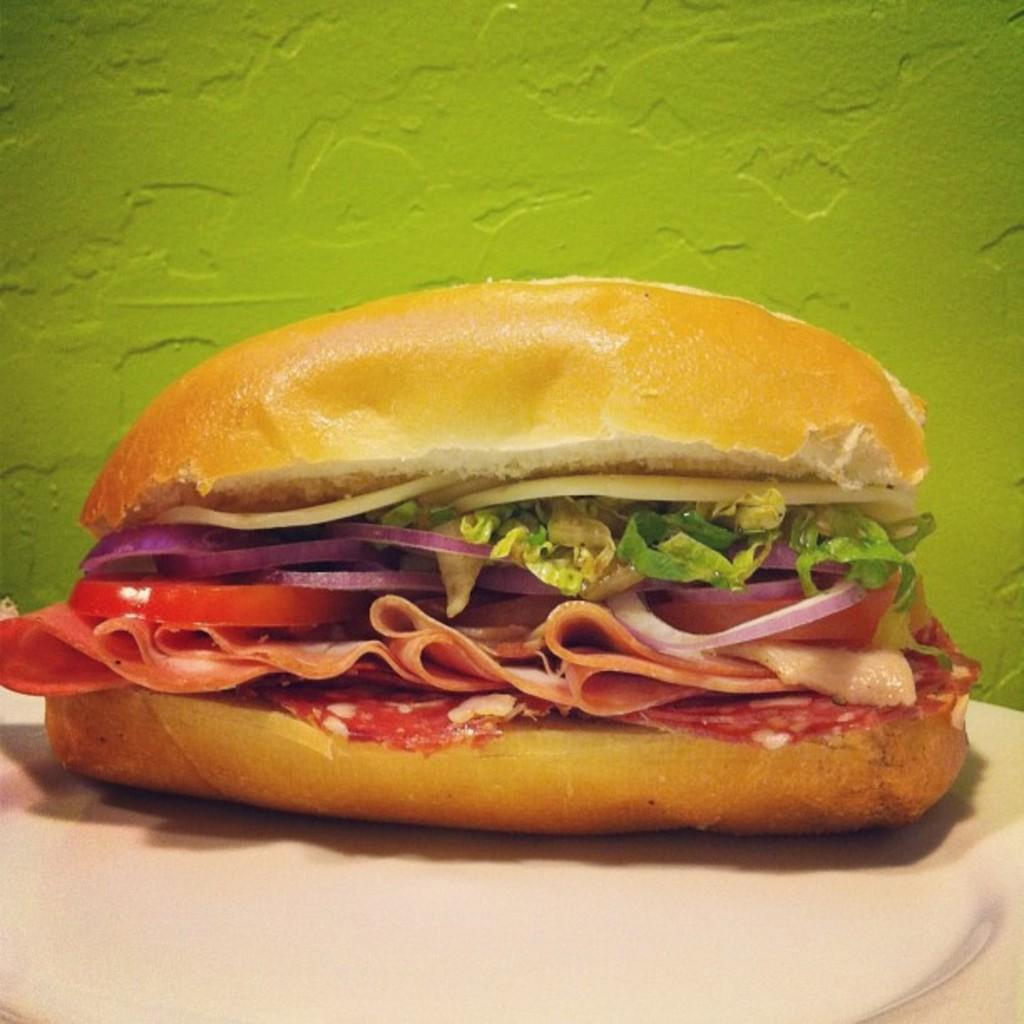What type of food is visible in the image? There is a sandwich in the image. What can be seen on the table in the image? There are tissues placed on the table in the image. What color is the wall in the background of the image? There is a green color wall in the backdrop of the image. What is the chance of a protest happening in the image? There is no indication of a protest in the image, so it is not possible to determine the chance of one occurring. 